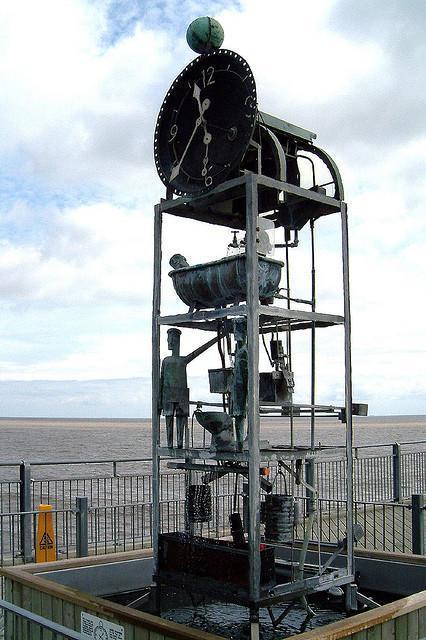How many clocks can be seen?
Give a very brief answer. 1. How many people are wearing glasses?
Give a very brief answer. 0. 